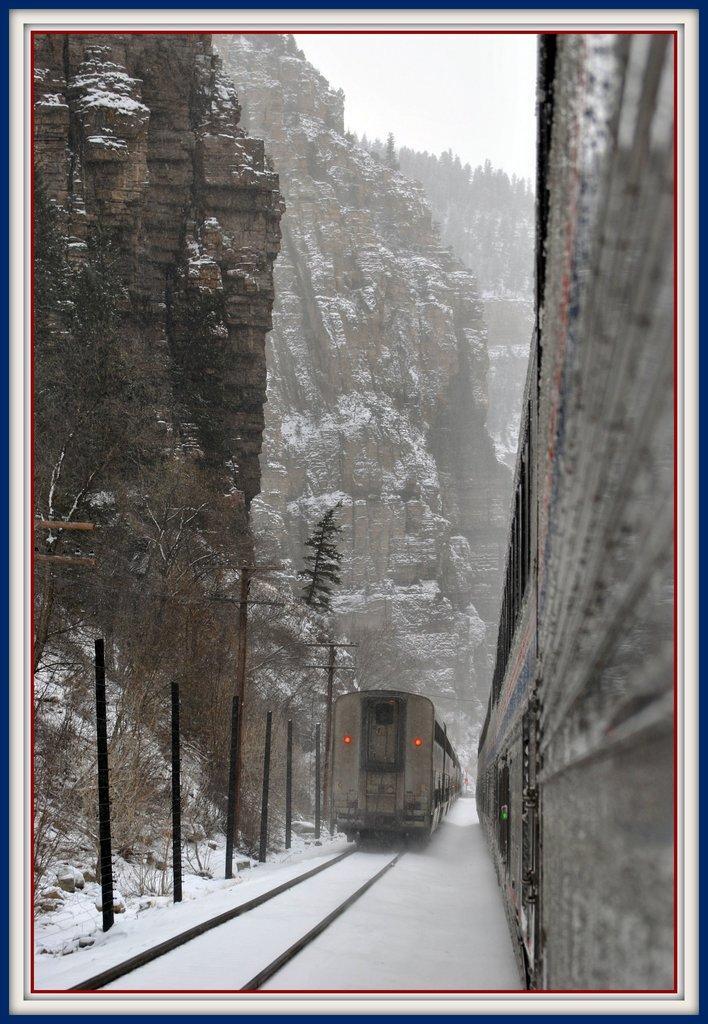Can you describe this image briefly? In this black and white picture we can see trains on the railway tracks covered with snow and surrounded by mountains, trees and poles. 